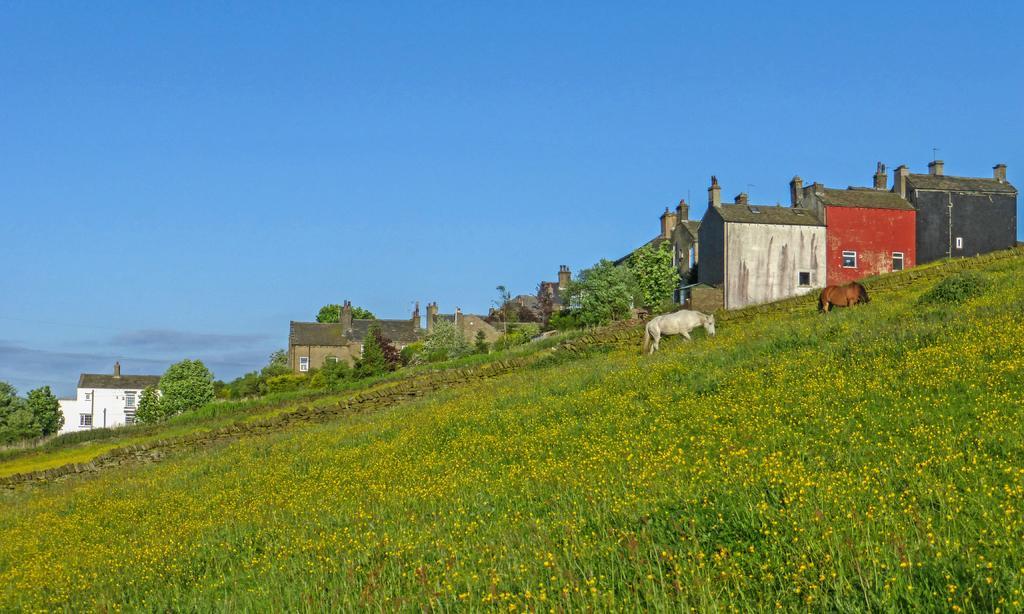In one or two sentences, can you explain what this image depicts? In this image I can see two animals, they are in brown and white color, and I can see grass in green and trees in green color, few buildings in white, gray, red and black color, and sky is in blue color. 